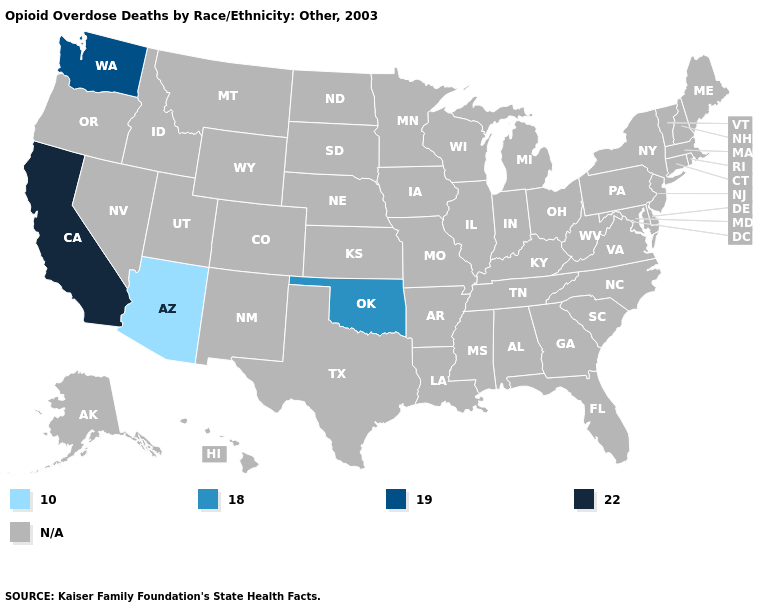What is the value of Alaska?
Keep it brief. N/A. Does the map have missing data?
Short answer required. Yes. Which states have the highest value in the USA?
Be succinct. California. What is the value of Michigan?
Keep it brief. N/A. Which states have the lowest value in the USA?
Write a very short answer. Arizona. What is the lowest value in the USA?
Be succinct. 10.0. Name the states that have a value in the range 18.0?
Quick response, please. Oklahoma. Does Arizona have the lowest value in the USA?
Keep it brief. Yes. Name the states that have a value in the range 22.0?
Give a very brief answer. California. How many symbols are there in the legend?
Answer briefly. 5. Does California have the lowest value in the West?
Short answer required. No. 